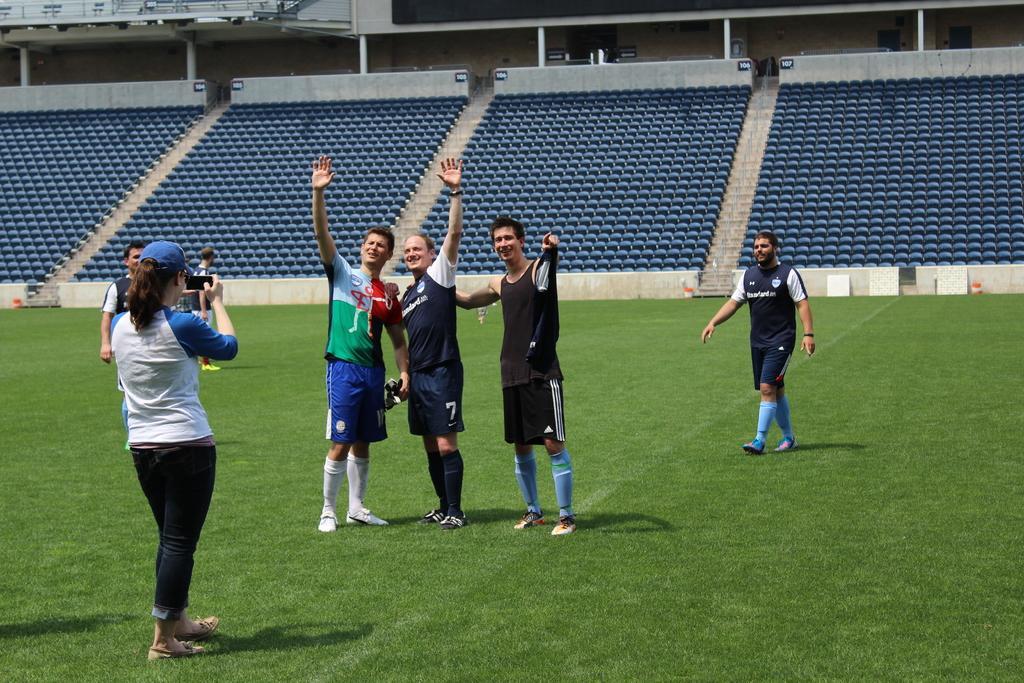Please provide a concise description of this image. In this image there is a stadium, there are persons standing, there are persons holding objects, there is a person walking, there is grass, there are chairs, there are pillars, there is wall truncated towards the top of the image, there are boards, there is text on the boards. 